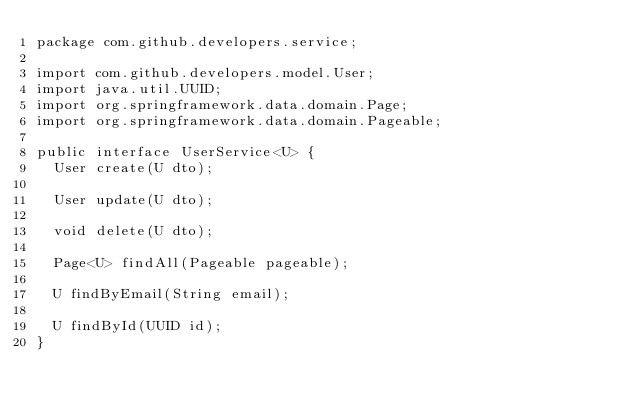<code> <loc_0><loc_0><loc_500><loc_500><_Java_>package com.github.developers.service;

import com.github.developers.model.User;
import java.util.UUID;
import org.springframework.data.domain.Page;
import org.springframework.data.domain.Pageable;

public interface UserService<U> {
  User create(U dto);

  User update(U dto);

  void delete(U dto);

  Page<U> findAll(Pageable pageable);

  U findByEmail(String email);

  U findById(UUID id);
}
</code> 